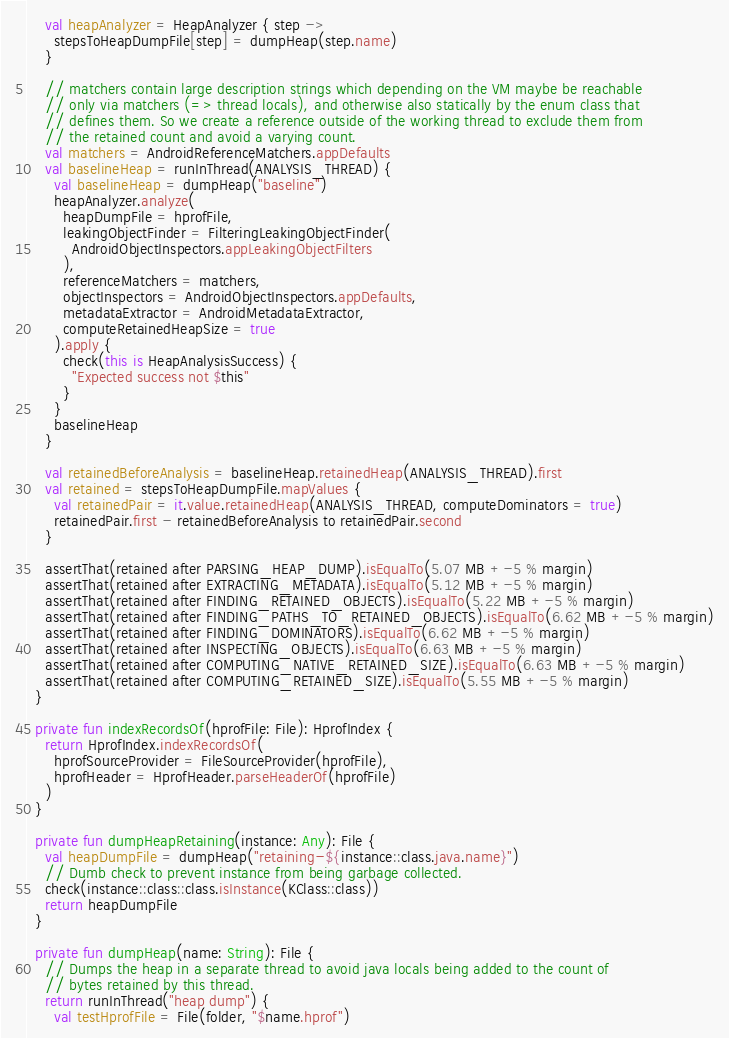Convert code to text. <code><loc_0><loc_0><loc_500><loc_500><_Kotlin_>    val heapAnalyzer = HeapAnalyzer { step ->
      stepsToHeapDumpFile[step] = dumpHeap(step.name)
    }

    // matchers contain large description strings which depending on the VM maybe be reachable
    // only via matchers (=> thread locals), and otherwise also statically by the enum class that
    // defines them. So we create a reference outside of the working thread to exclude them from
    // the retained count and avoid a varying count.
    val matchers = AndroidReferenceMatchers.appDefaults
    val baselineHeap = runInThread(ANALYSIS_THREAD) {
      val baselineHeap = dumpHeap("baseline")
      heapAnalyzer.analyze(
        heapDumpFile = hprofFile,
        leakingObjectFinder = FilteringLeakingObjectFinder(
          AndroidObjectInspectors.appLeakingObjectFilters
        ),
        referenceMatchers = matchers,
        objectInspectors = AndroidObjectInspectors.appDefaults,
        metadataExtractor = AndroidMetadataExtractor,
        computeRetainedHeapSize = true
      ).apply {
        check(this is HeapAnalysisSuccess) {
          "Expected success not $this"
        }
      }
      baselineHeap
    }

    val retainedBeforeAnalysis = baselineHeap.retainedHeap(ANALYSIS_THREAD).first
    val retained = stepsToHeapDumpFile.mapValues {
      val retainedPair = it.value.retainedHeap(ANALYSIS_THREAD, computeDominators = true)
      retainedPair.first - retainedBeforeAnalysis to retainedPair.second
    }

    assertThat(retained after PARSING_HEAP_DUMP).isEqualTo(5.07 MB +-5 % margin)
    assertThat(retained after EXTRACTING_METADATA).isEqualTo(5.12 MB +-5 % margin)
    assertThat(retained after FINDING_RETAINED_OBJECTS).isEqualTo(5.22 MB +-5 % margin)
    assertThat(retained after FINDING_PATHS_TO_RETAINED_OBJECTS).isEqualTo(6.62 MB +-5 % margin)
    assertThat(retained after FINDING_DOMINATORS).isEqualTo(6.62 MB +-5 % margin)
    assertThat(retained after INSPECTING_OBJECTS).isEqualTo(6.63 MB +-5 % margin)
    assertThat(retained after COMPUTING_NATIVE_RETAINED_SIZE).isEqualTo(6.63 MB +-5 % margin)
    assertThat(retained after COMPUTING_RETAINED_SIZE).isEqualTo(5.55 MB +-5 % margin)
  }

  private fun indexRecordsOf(hprofFile: File): HprofIndex {
    return HprofIndex.indexRecordsOf(
      hprofSourceProvider = FileSourceProvider(hprofFile),
      hprofHeader = HprofHeader.parseHeaderOf(hprofFile)
    )
  }

  private fun dumpHeapRetaining(instance: Any): File {
    val heapDumpFile = dumpHeap("retaining-${instance::class.java.name}")
    // Dumb check to prevent instance from being garbage collected.
    check(instance::class::class.isInstance(KClass::class))
    return heapDumpFile
  }

  private fun dumpHeap(name: String): File {
    // Dumps the heap in a separate thread to avoid java locals being added to the count of
    // bytes retained by this thread.
    return runInThread("heap dump") {
      val testHprofFile = File(folder, "$name.hprof")</code> 